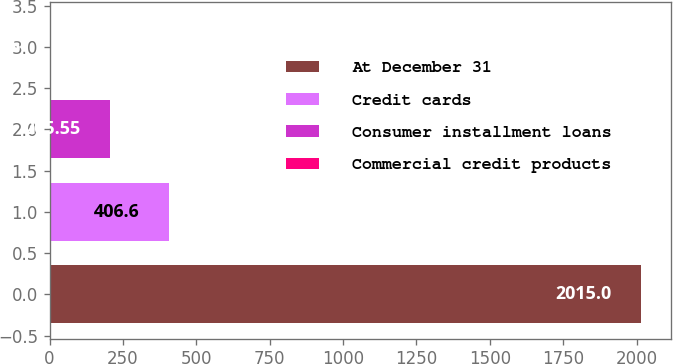Convert chart. <chart><loc_0><loc_0><loc_500><loc_500><bar_chart><fcel>At December 31<fcel>Credit cards<fcel>Consumer installment loans<fcel>Commercial credit products<nl><fcel>2015<fcel>406.6<fcel>205.55<fcel>4.5<nl></chart> 